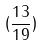<formula> <loc_0><loc_0><loc_500><loc_500>( \frac { 1 3 } { 1 9 } )</formula> 